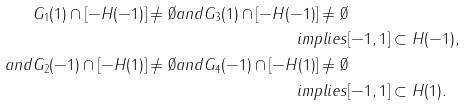Convert formula to latex. <formula><loc_0><loc_0><loc_500><loc_500>G _ { 1 } ( 1 ) \cap [ - H ( - 1 ) ] \neq \emptyset a n d G _ { 3 } ( 1 ) \cap [ - H ( - 1 ) ] \neq \emptyset \\ i m p l i e s & [ - 1 , 1 ] \subset H ( - 1 ) , \\ a n d G _ { 2 } ( - 1 ) \cap [ - H ( 1 ) ] \neq \emptyset a n d G _ { 4 } ( - 1 ) \cap [ - H ( 1 ) ] \neq \emptyset \\ i m p l i e s & [ - 1 , 1 ] \subset H ( 1 ) .</formula> 